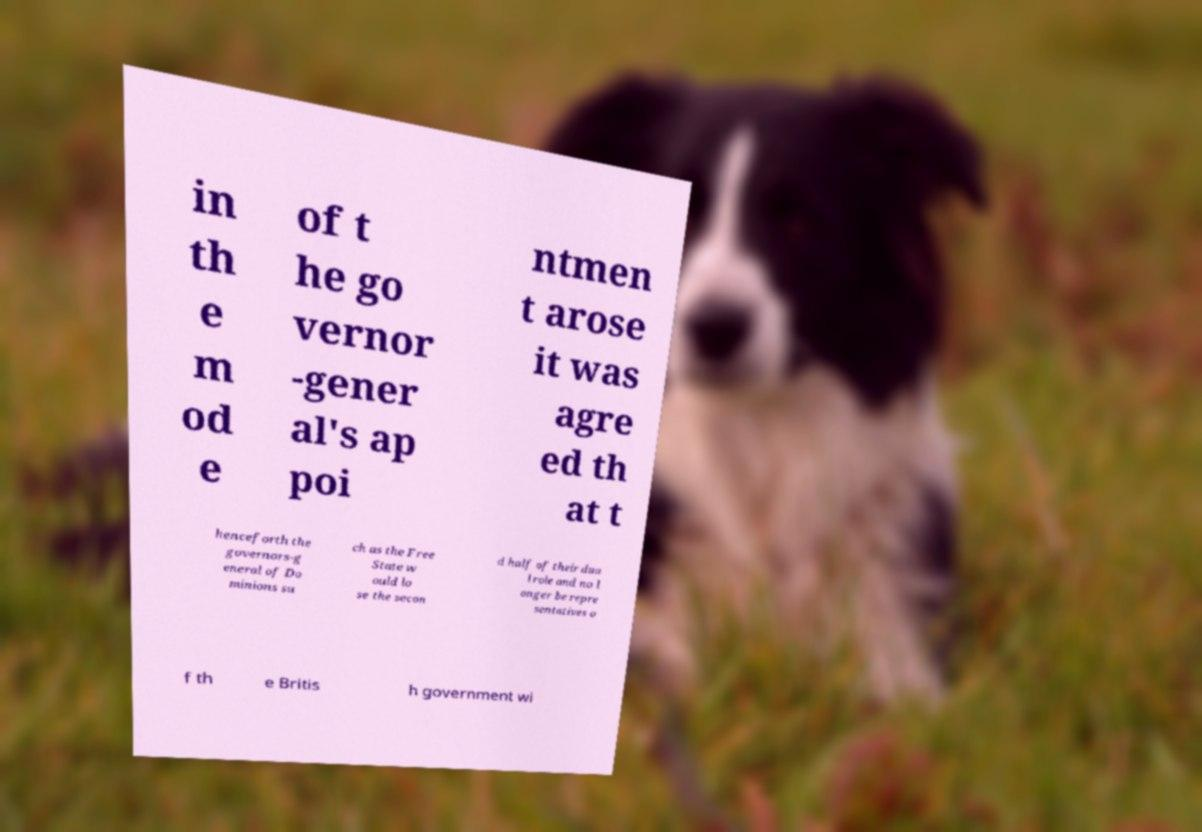Can you accurately transcribe the text from the provided image for me? in th e m od e of t he go vernor -gener al's ap poi ntmen t arose it was agre ed th at t henceforth the governors-g eneral of Do minions su ch as the Free State w ould lo se the secon d half of their dua l role and no l onger be repre sentatives o f th e Britis h government wi 